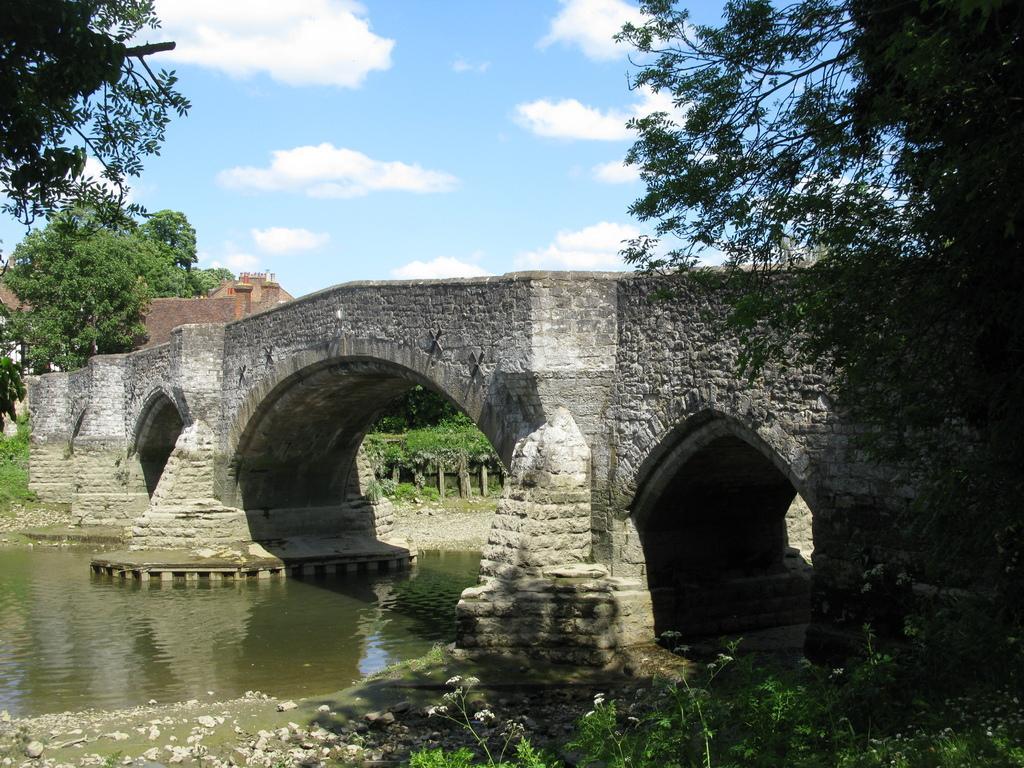In one or two sentences, can you explain what this image depicts? In the center of the image, we can see a bridge and there is a building and we can see trees. At the bottom, there is water and some plants and at the top, there are clouds in the sky. 